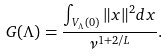Convert formula to latex. <formula><loc_0><loc_0><loc_500><loc_500>G ( \Lambda ) = \frac { \int _ { V _ { \Lambda } ( 0 ) } \| x \| ^ { 2 } d x } { \nu ^ { 1 + 2 / L } } .</formula> 